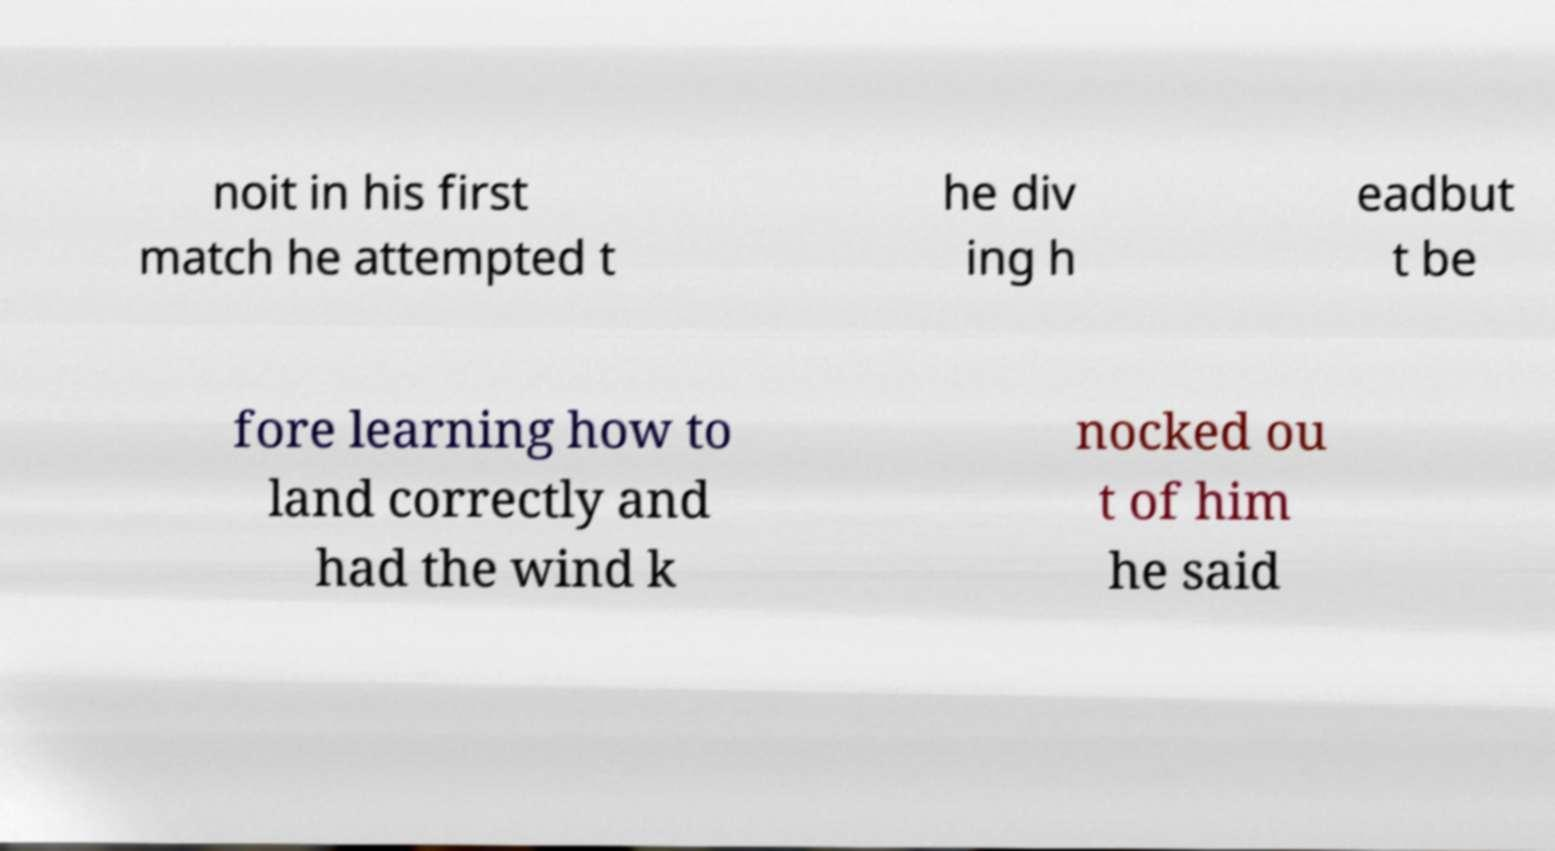Please read and relay the text visible in this image. What does it say? noit in his first match he attempted t he div ing h eadbut t be fore learning how to land correctly and had the wind k nocked ou t of him he said 